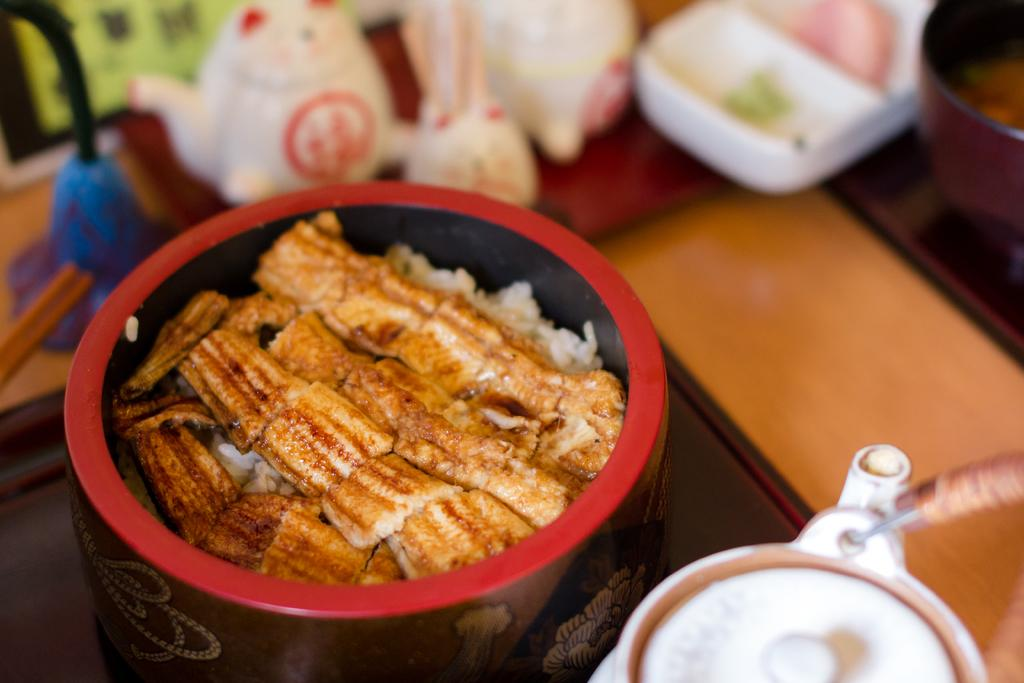What type of containers are present in the image? There are bowls in the image. What is inside the containers? There are food items in the image. Can you describe any other objects in the image? The specific nature of the additional objects is not clear from the provided facts. What type of coal is being used to fuel the song in the image? There is no coal or song present in the image; it features bowls with food items and additional unspecified objects. 